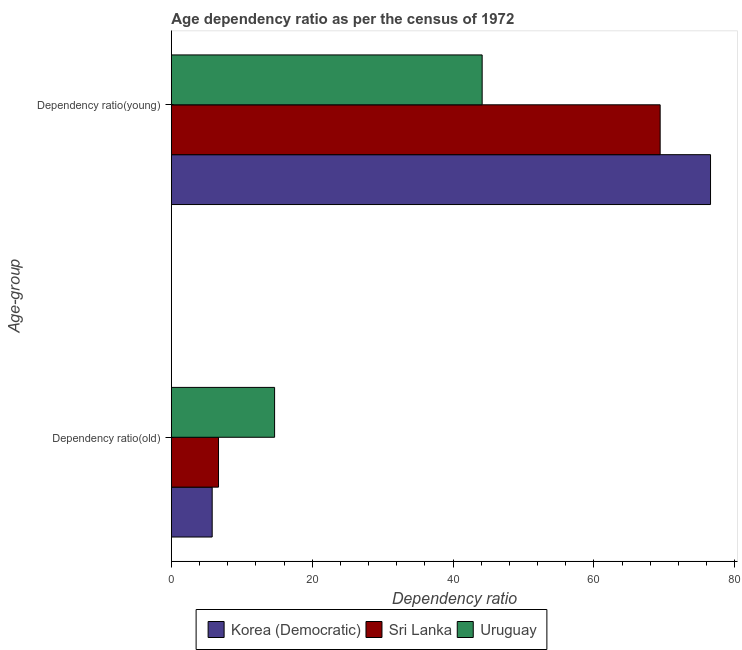How many different coloured bars are there?
Provide a succinct answer. 3. Are the number of bars per tick equal to the number of legend labels?
Offer a terse response. Yes. What is the label of the 2nd group of bars from the top?
Your response must be concise. Dependency ratio(old). What is the age dependency ratio(old) in Sri Lanka?
Your answer should be very brief. 6.69. Across all countries, what is the maximum age dependency ratio(old)?
Give a very brief answer. 14.65. Across all countries, what is the minimum age dependency ratio(old)?
Provide a short and direct response. 5.8. In which country was the age dependency ratio(old) maximum?
Your answer should be compact. Uruguay. In which country was the age dependency ratio(old) minimum?
Provide a short and direct response. Korea (Democratic). What is the total age dependency ratio(old) in the graph?
Your answer should be compact. 27.14. What is the difference between the age dependency ratio(old) in Korea (Democratic) and that in Sri Lanka?
Ensure brevity in your answer.  -0.9. What is the difference between the age dependency ratio(old) in Korea (Democratic) and the age dependency ratio(young) in Sri Lanka?
Ensure brevity in your answer.  -63.61. What is the average age dependency ratio(young) per country?
Your response must be concise. 63.36. What is the difference between the age dependency ratio(young) and age dependency ratio(old) in Korea (Democratic)?
Ensure brevity in your answer.  70.76. In how many countries, is the age dependency ratio(old) greater than 60 ?
Offer a very short reply. 0. What is the ratio of the age dependency ratio(young) in Korea (Democratic) to that in Uruguay?
Offer a terse response. 1.73. In how many countries, is the age dependency ratio(old) greater than the average age dependency ratio(old) taken over all countries?
Your answer should be compact. 1. What does the 2nd bar from the top in Dependency ratio(young) represents?
Your response must be concise. Sri Lanka. What does the 1st bar from the bottom in Dependency ratio(young) represents?
Provide a short and direct response. Korea (Democratic). How many bars are there?
Offer a very short reply. 6. Are all the bars in the graph horizontal?
Provide a short and direct response. Yes. Does the graph contain grids?
Ensure brevity in your answer.  No. Where does the legend appear in the graph?
Your response must be concise. Bottom center. How are the legend labels stacked?
Ensure brevity in your answer.  Horizontal. What is the title of the graph?
Give a very brief answer. Age dependency ratio as per the census of 1972. Does "Tuvalu" appear as one of the legend labels in the graph?
Ensure brevity in your answer.  No. What is the label or title of the X-axis?
Ensure brevity in your answer.  Dependency ratio. What is the label or title of the Y-axis?
Your answer should be very brief. Age-group. What is the Dependency ratio in Korea (Democratic) in Dependency ratio(old)?
Your answer should be very brief. 5.8. What is the Dependency ratio of Sri Lanka in Dependency ratio(old)?
Ensure brevity in your answer.  6.69. What is the Dependency ratio of Uruguay in Dependency ratio(old)?
Your answer should be very brief. 14.65. What is the Dependency ratio of Korea (Democratic) in Dependency ratio(young)?
Your answer should be compact. 76.55. What is the Dependency ratio in Sri Lanka in Dependency ratio(young)?
Ensure brevity in your answer.  69.4. What is the Dependency ratio of Uruguay in Dependency ratio(young)?
Your response must be concise. 44.13. Across all Age-group, what is the maximum Dependency ratio in Korea (Democratic)?
Your response must be concise. 76.55. Across all Age-group, what is the maximum Dependency ratio in Sri Lanka?
Offer a very short reply. 69.4. Across all Age-group, what is the maximum Dependency ratio of Uruguay?
Provide a succinct answer. 44.13. Across all Age-group, what is the minimum Dependency ratio of Korea (Democratic)?
Make the answer very short. 5.8. Across all Age-group, what is the minimum Dependency ratio in Sri Lanka?
Offer a very short reply. 6.69. Across all Age-group, what is the minimum Dependency ratio of Uruguay?
Make the answer very short. 14.65. What is the total Dependency ratio in Korea (Democratic) in the graph?
Offer a very short reply. 82.35. What is the total Dependency ratio in Sri Lanka in the graph?
Make the answer very short. 76.09. What is the total Dependency ratio in Uruguay in the graph?
Keep it short and to the point. 58.78. What is the difference between the Dependency ratio in Korea (Democratic) in Dependency ratio(old) and that in Dependency ratio(young)?
Offer a very short reply. -70.76. What is the difference between the Dependency ratio in Sri Lanka in Dependency ratio(old) and that in Dependency ratio(young)?
Offer a terse response. -62.71. What is the difference between the Dependency ratio of Uruguay in Dependency ratio(old) and that in Dependency ratio(young)?
Offer a very short reply. -29.47. What is the difference between the Dependency ratio in Korea (Democratic) in Dependency ratio(old) and the Dependency ratio in Sri Lanka in Dependency ratio(young)?
Provide a succinct answer. -63.61. What is the difference between the Dependency ratio of Korea (Democratic) in Dependency ratio(old) and the Dependency ratio of Uruguay in Dependency ratio(young)?
Provide a succinct answer. -38.33. What is the difference between the Dependency ratio of Sri Lanka in Dependency ratio(old) and the Dependency ratio of Uruguay in Dependency ratio(young)?
Your answer should be compact. -37.44. What is the average Dependency ratio of Korea (Democratic) per Age-group?
Provide a short and direct response. 41.17. What is the average Dependency ratio of Sri Lanka per Age-group?
Give a very brief answer. 38.05. What is the average Dependency ratio in Uruguay per Age-group?
Your answer should be very brief. 29.39. What is the difference between the Dependency ratio of Korea (Democratic) and Dependency ratio of Sri Lanka in Dependency ratio(old)?
Ensure brevity in your answer.  -0.9. What is the difference between the Dependency ratio of Korea (Democratic) and Dependency ratio of Uruguay in Dependency ratio(old)?
Ensure brevity in your answer.  -8.86. What is the difference between the Dependency ratio of Sri Lanka and Dependency ratio of Uruguay in Dependency ratio(old)?
Keep it short and to the point. -7.96. What is the difference between the Dependency ratio of Korea (Democratic) and Dependency ratio of Sri Lanka in Dependency ratio(young)?
Offer a very short reply. 7.15. What is the difference between the Dependency ratio of Korea (Democratic) and Dependency ratio of Uruguay in Dependency ratio(young)?
Make the answer very short. 32.43. What is the difference between the Dependency ratio of Sri Lanka and Dependency ratio of Uruguay in Dependency ratio(young)?
Provide a succinct answer. 25.27. What is the ratio of the Dependency ratio of Korea (Democratic) in Dependency ratio(old) to that in Dependency ratio(young)?
Your response must be concise. 0.08. What is the ratio of the Dependency ratio in Sri Lanka in Dependency ratio(old) to that in Dependency ratio(young)?
Your response must be concise. 0.1. What is the ratio of the Dependency ratio in Uruguay in Dependency ratio(old) to that in Dependency ratio(young)?
Offer a very short reply. 0.33. What is the difference between the highest and the second highest Dependency ratio of Korea (Democratic)?
Your answer should be compact. 70.76. What is the difference between the highest and the second highest Dependency ratio of Sri Lanka?
Offer a terse response. 62.71. What is the difference between the highest and the second highest Dependency ratio in Uruguay?
Provide a short and direct response. 29.47. What is the difference between the highest and the lowest Dependency ratio of Korea (Democratic)?
Offer a very short reply. 70.76. What is the difference between the highest and the lowest Dependency ratio of Sri Lanka?
Keep it short and to the point. 62.71. What is the difference between the highest and the lowest Dependency ratio in Uruguay?
Make the answer very short. 29.47. 